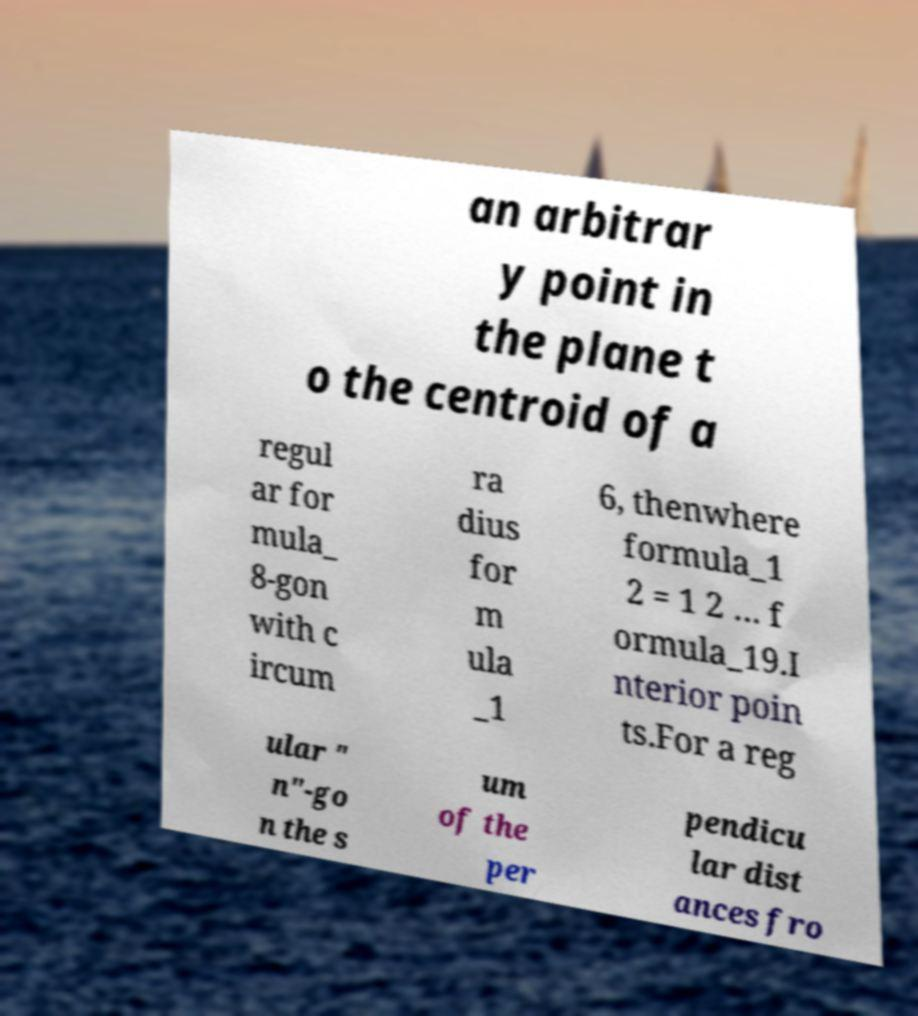Can you read and provide the text displayed in the image?This photo seems to have some interesting text. Can you extract and type it out for me? an arbitrar y point in the plane t o the centroid of a regul ar for mula_ 8-gon with c ircum ra dius for m ula _1 6, thenwhere formula_1 2 = 1 2 … f ormula_19.I nterior poin ts.For a reg ular " n"-go n the s um of the per pendicu lar dist ances fro 